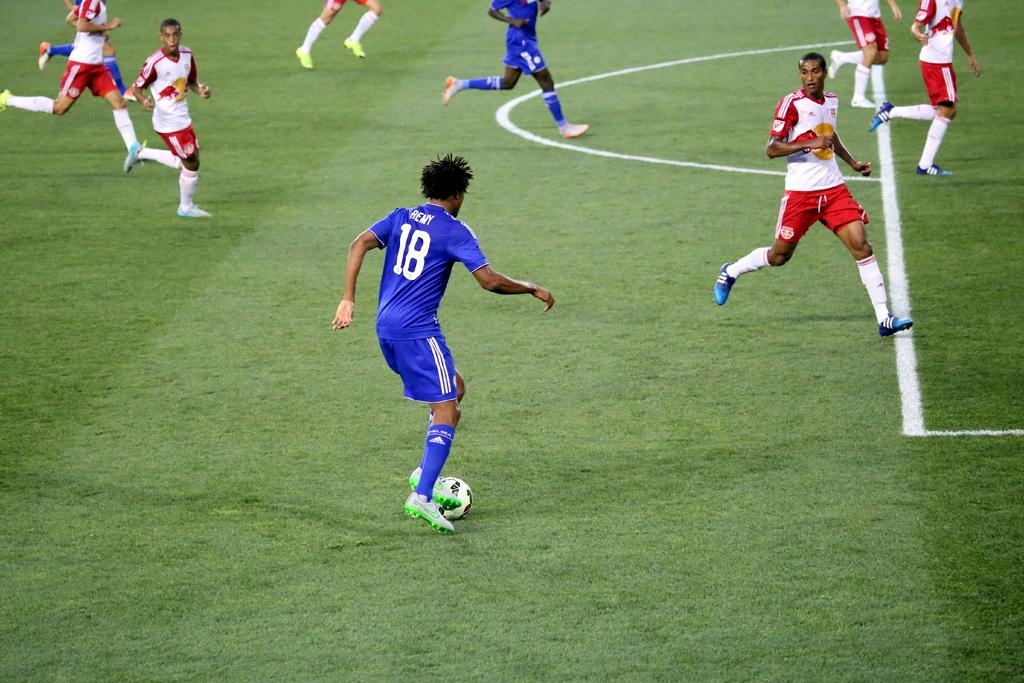How many people are in the image? There are people in the image, but the exact number is not specified. What type of clothing are the people wearing? The people are wearing sports dress. What activity are the people engaged in? The people are playing on the ground, and they appear to be playing football. What object is associated with the game they are playing? There is a ball in the image. Can you read the letter that the sun is holding in the image? There is no letter or sun present in the image. The people are playing football, and the focus is on their activity and the ball. 